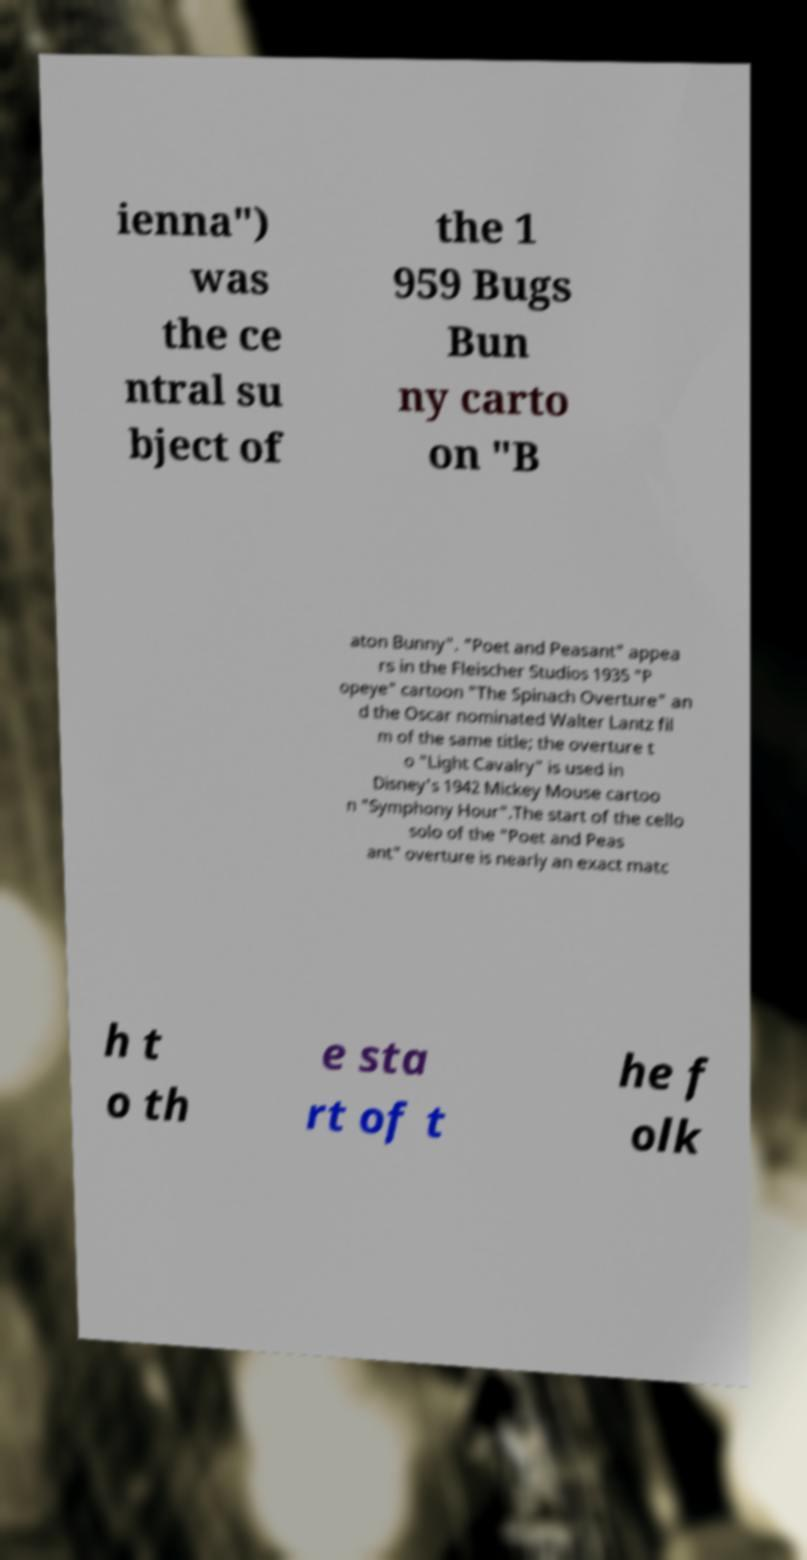Can you accurately transcribe the text from the provided image for me? ienna") was the ce ntral su bject of the 1 959 Bugs Bun ny carto on "B aton Bunny". "Poet and Peasant" appea rs in the Fleischer Studios 1935 "P opeye" cartoon "The Spinach Overture" an d the Oscar nominated Walter Lantz fil m of the same title; the overture t o "Light Cavalry" is used in Disney's 1942 Mickey Mouse cartoo n "Symphony Hour".The start of the cello solo of the "Poet and Peas ant" overture is nearly an exact matc h t o th e sta rt of t he f olk 